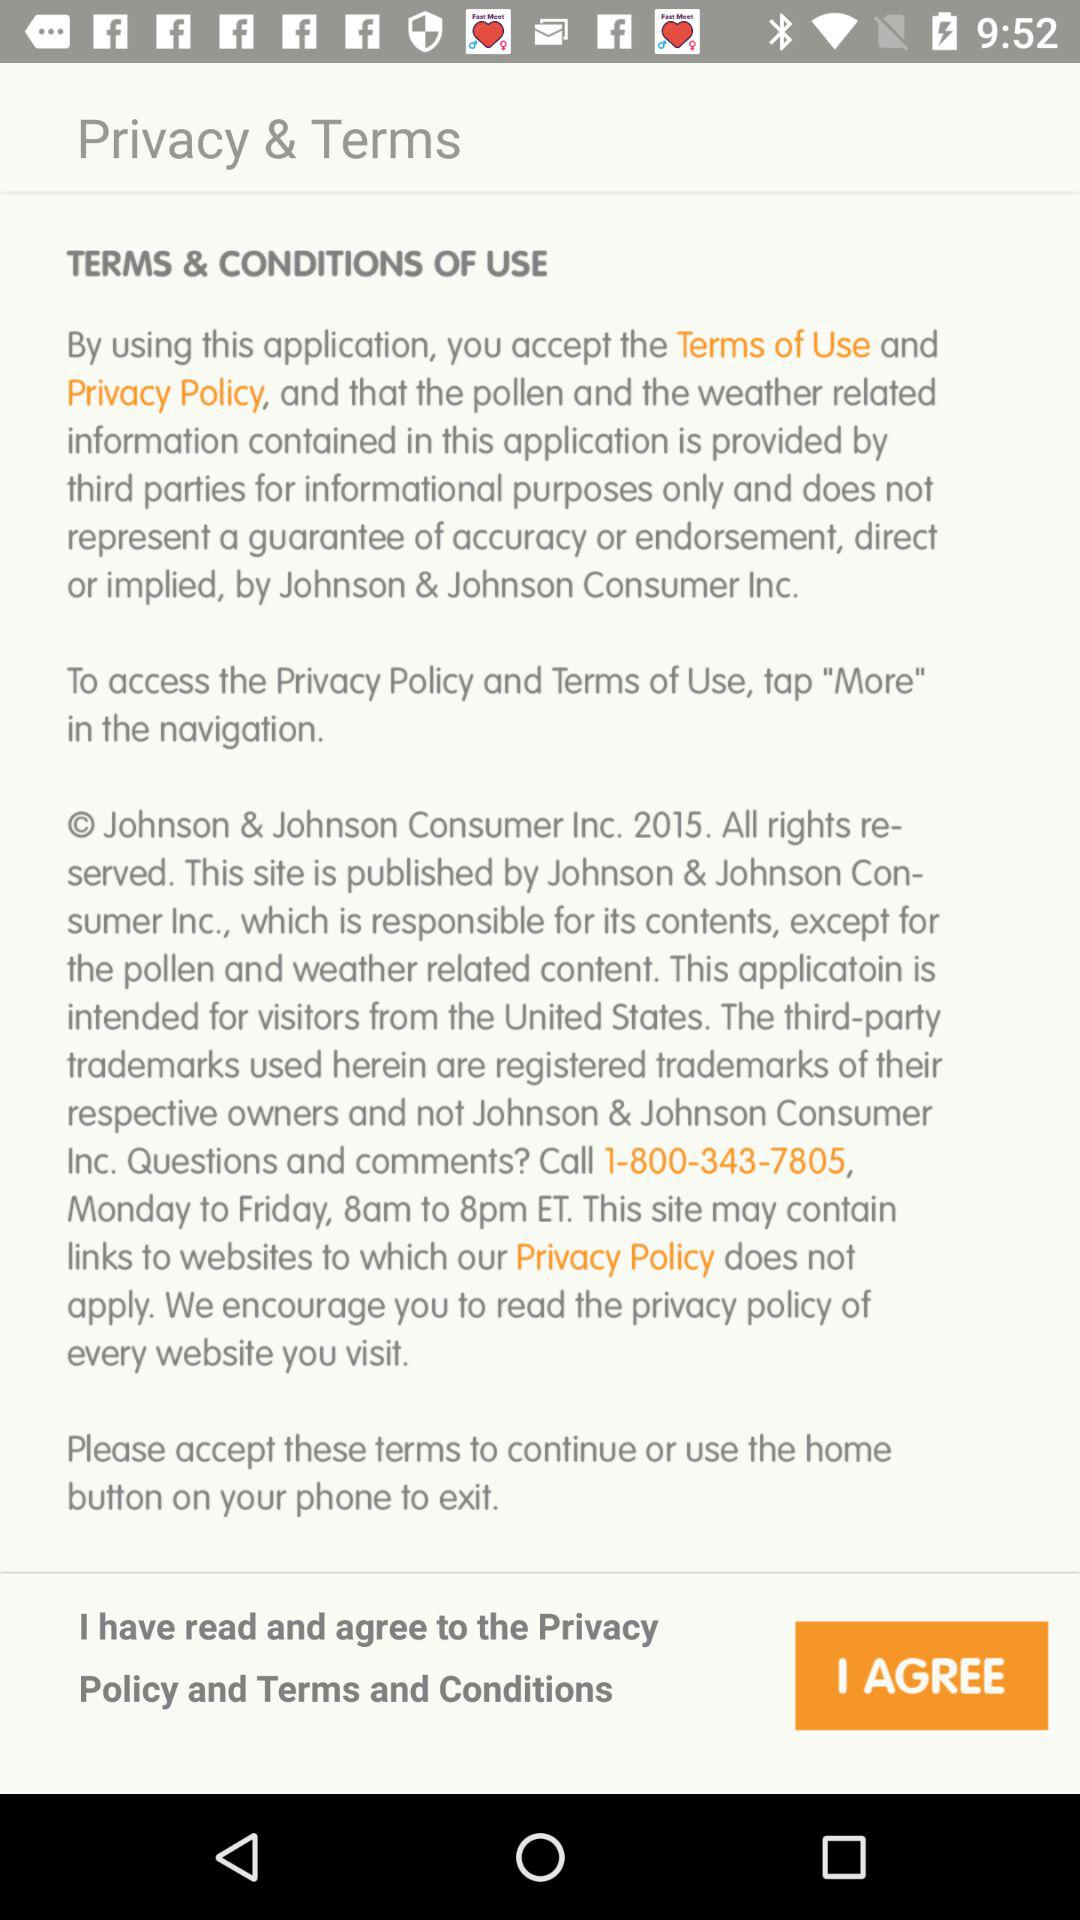What are the privacy and terms? The privacy and terms of service are "By using this application, you accept the Terms of Use and Privacy Policy, and that the pollen and the weather related information contained in this application is provided by third parties for informational purposes only and does not represent a guarantee of accuracy or endorsement, direct or implied, by Johnson & Johnson Consumer Inc." and "© Johnson & Johnson Consumer Inc. 2015. All rights reserved. This site is published by Johnson & Johnson Consumer Inc., which is responsible for its contents, except for the pollen weather related content. This application is intended for visitors from the Unites States. The third-party trademarks used herein are registered trademarks of their respective owners and not Johnson & Johnson Consumer Inc. Questions and comments? Call 1-800-343-7805, Monday to Friday, 8am to 8pm ET. This site may contain links to websites to which our Privacy Policy does not apply. We encourage you to read the privacy policy of every website you visit.". 